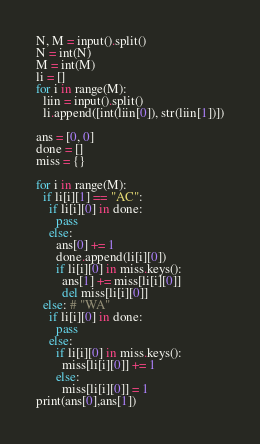Convert code to text. <code><loc_0><loc_0><loc_500><loc_500><_Python_>N, M = input().split()
N = int(N)
M = int(M)
li = []
for i in range(M):
  liin = input().split()
  li.append([int(liin[0]), str(liin[1])])

ans = [0, 0]
done = []
miss = {}

for i in range(M):
  if li[i][1] == "AC":
    if li[i][0] in done:
      pass
    else:
      ans[0] += 1
      done.append(li[i][0])
      if li[i][0] in miss.keys():
        ans[1] += miss[li[i][0]]
        del miss[li[i][0]]
  else: # "WA"
    if li[i][0] in done:
      pass
    else:
      if li[i][0] in miss.keys():
        miss[li[i][0]] += 1
      else:
        miss[li[i][0]] = 1
print(ans[0],ans[1])</code> 